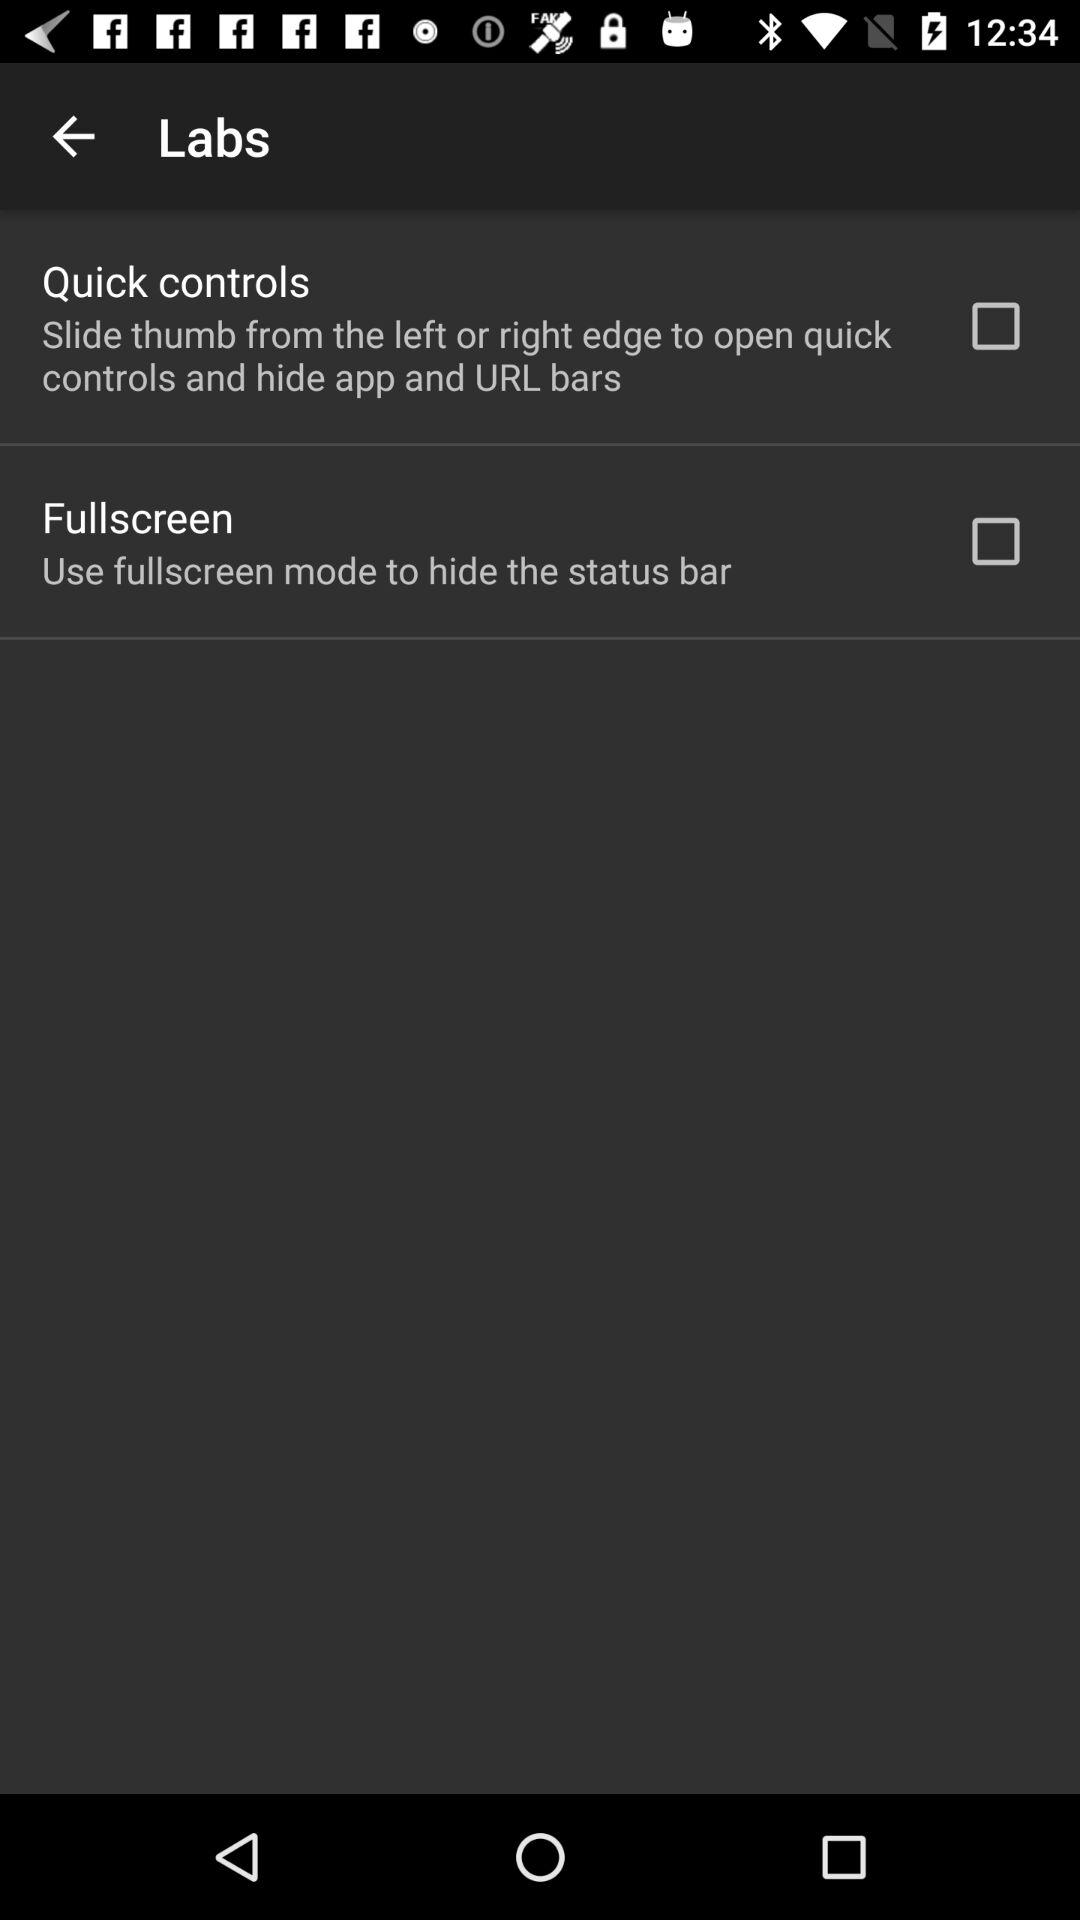How many labs features are there?
Answer the question using a single word or phrase. 2 